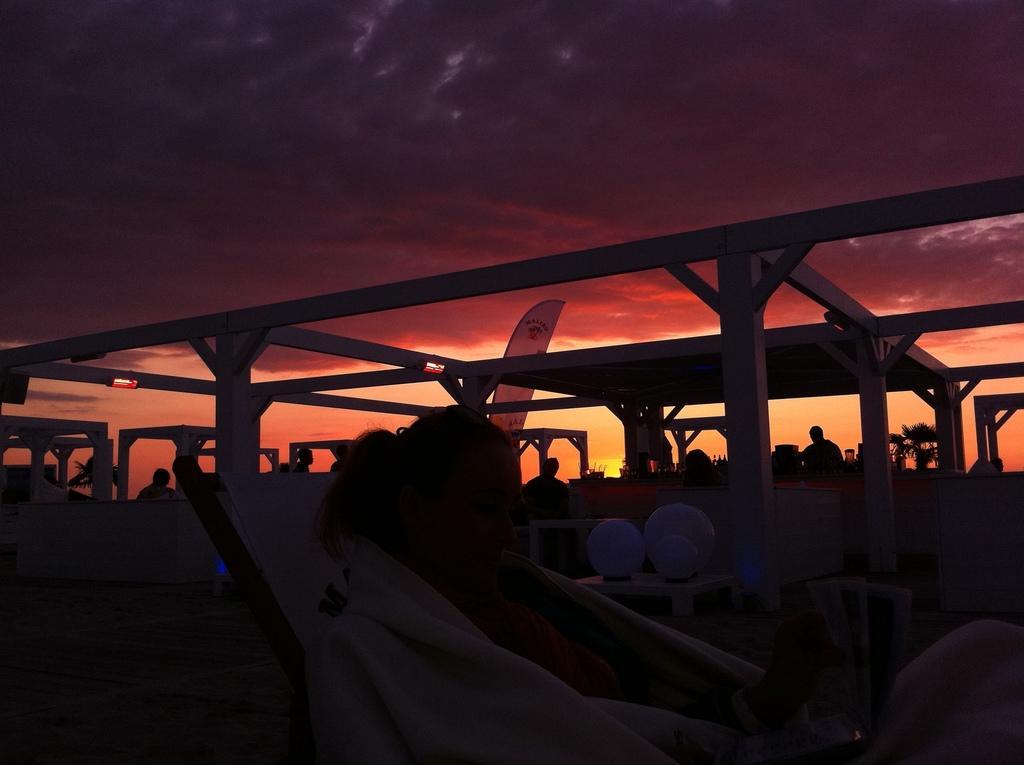Describe this image in one or two sentences. There is a lady sitting on a chair is wearing a towel. In the back there are pillars. Also there are many people. There are tables with lamp. In the background there is sky. 